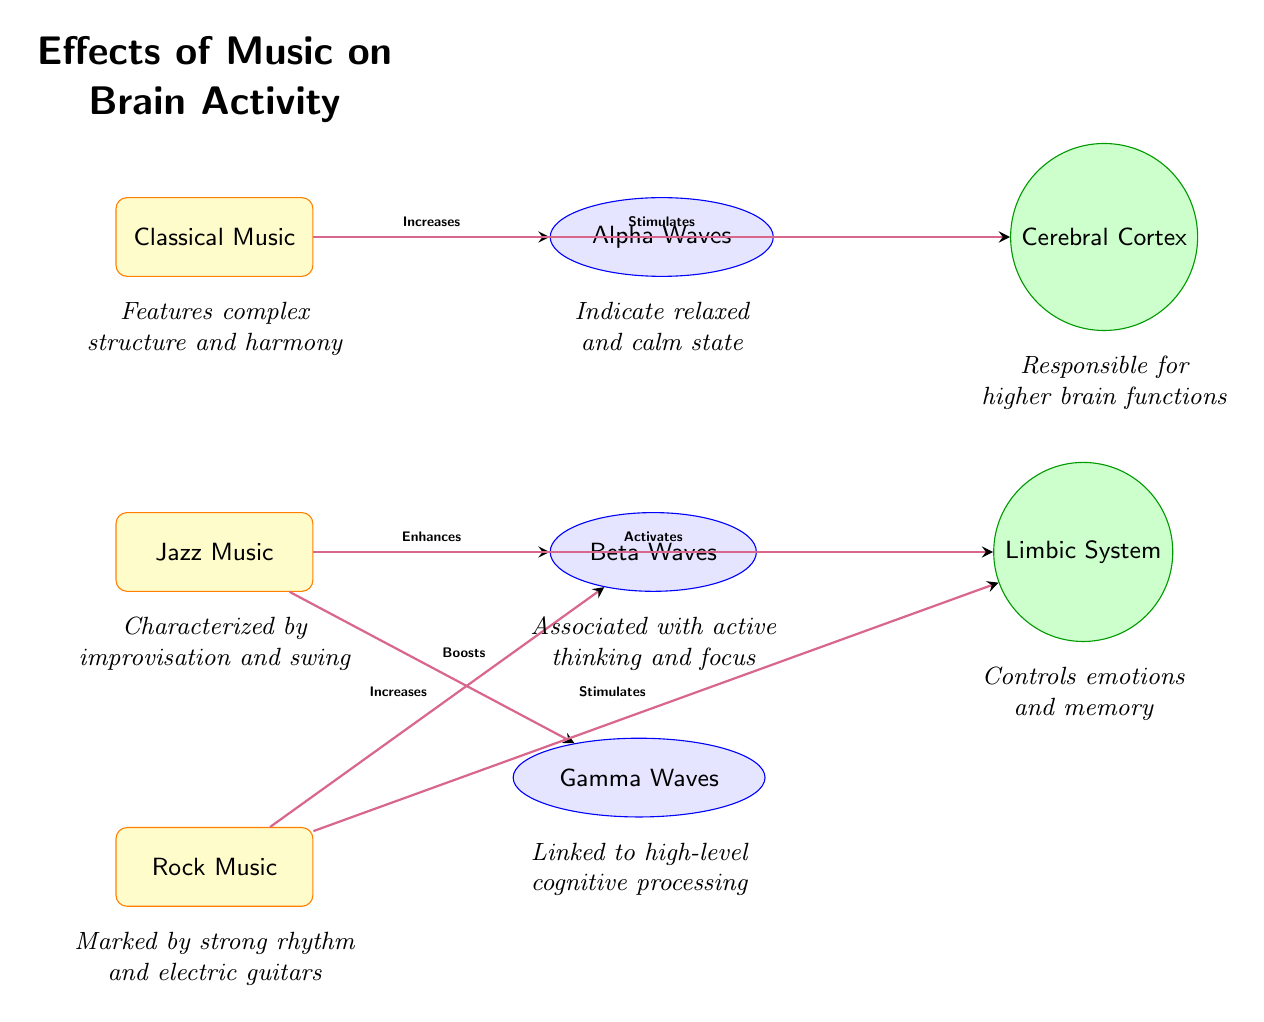What type of music is associated with Alpha Waves? The diagram shows a connection from the Classical Music node to the Alpha Waves node, indicating that Classical Music is associated with Alpha Waves.
Answer: Classical Music Which brain region is stimulated by Jazz Music? The diagram indicates that Jazz Music activates the Limbic System, as shown by the directed edge from the Jazz Music node to the Limbic System node.
Answer: Limbic System How many types of music are represented in the diagram? The diagram clearly displays three music types: Classical Music, Jazz Music, and Rock Music, as seen in the nodes on the left side.
Answer: Three What brainwave is linked to high-level cognitive processing? The diagram labels the Gamma Waves node with a note stating that it is linked to high-level cognitive processing, which means the answer is found in that context.
Answer: Gamma Waves Which type of music enhances Beta Waves? The diagram shows a direct connection from the Jazz Music node to the Beta Waves node, indicating that Jazz Music enhances Beta Waves.
Answer: Jazz Music What happens to the Limbic System when Classical Music is played? The diagram shows that Classical Music does not connect to the Limbic System, so we look for other music types connected to it. This leads us to realize that only Jazz and Rock Music stimulate the Limbic System.
Answer: No increase How do the effects of Rock Music compare to those of Jazz Music on Beta Waves? Both the Rock Music and Jazz Music nodes show arrows leading to the Beta Waves node, which indicates that both types of music increase Beta Waves. However, the effect of Jazz is labeled as "Enhances" while Rock is labeled "Increases."
Answer: Both increase What characteristic of Classical Music is mentioned in the diagram? The diagram provides an annotation below the Classical Music node stating that it features complex structure and harmony, providing insight into its defining characteristics.
Answer: Complex structure and harmony Which music type activates the Cerebral Cortex? Referring to the diagram, Classical Music has an arrow leading to the Cerebral Cortex labeled "Stimulates," which identifies the effect of that music type on the specified brain region.
Answer: Classical Music What is the relationship between Jazz Music and Gamma Waves? The diagram shows that Jazz Music has a directed edge to the Gamma Waves node labeled "Boosts," indicating a relationship where Jazz Music enhances Gamma Waves.
Answer: Boosts 